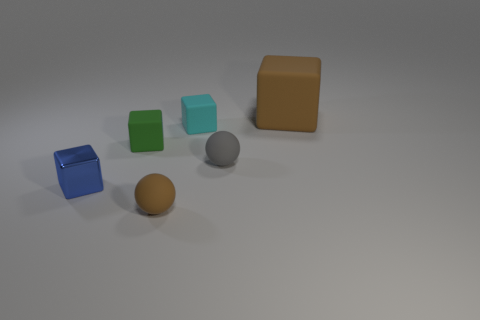What number of things are spheres that are on the left side of the cyan rubber cube or brown things to the left of the gray ball?
Your answer should be compact. 1. There is a brown thing behind the blue metallic block; is there a cyan block that is to the left of it?
Provide a succinct answer. Yes. The cyan rubber object that is the same size as the green matte thing is what shape?
Keep it short and to the point. Cube. What number of objects are either objects that are on the left side of the big thing or large brown matte things?
Offer a very short reply. 6. What number of other objects are the same material as the tiny blue object?
Give a very brief answer. 0. What is the size of the brown matte object on the right side of the small gray matte thing?
Your response must be concise. Large. The gray thing that is made of the same material as the tiny brown sphere is what shape?
Provide a short and direct response. Sphere. Are the small gray object and the small block in front of the gray object made of the same material?
Make the answer very short. No. Do the brown thing in front of the green block and the gray object have the same shape?
Your answer should be compact. Yes. There is another big thing that is the same shape as the green matte thing; what is it made of?
Your response must be concise. Rubber. 